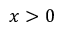<formula> <loc_0><loc_0><loc_500><loc_500>x > 0</formula> 